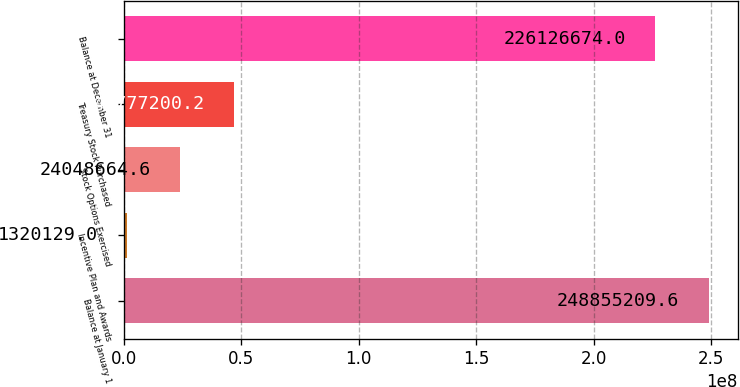Convert chart. <chart><loc_0><loc_0><loc_500><loc_500><bar_chart><fcel>Balance at January 1<fcel>Incentive Plan and Awards<fcel>Stock Options Exercised<fcel>Treasury Stock Purchased<fcel>Balance at December 31<nl><fcel>2.48855e+08<fcel>1.32013e+06<fcel>2.40487e+07<fcel>4.67772e+07<fcel>2.26127e+08<nl></chart> 